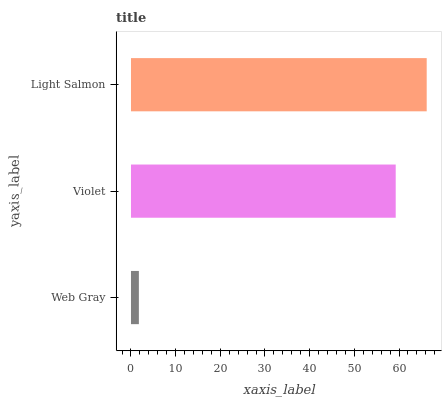Is Web Gray the minimum?
Answer yes or no. Yes. Is Light Salmon the maximum?
Answer yes or no. Yes. Is Violet the minimum?
Answer yes or no. No. Is Violet the maximum?
Answer yes or no. No. Is Violet greater than Web Gray?
Answer yes or no. Yes. Is Web Gray less than Violet?
Answer yes or no. Yes. Is Web Gray greater than Violet?
Answer yes or no. No. Is Violet less than Web Gray?
Answer yes or no. No. Is Violet the high median?
Answer yes or no. Yes. Is Violet the low median?
Answer yes or no. Yes. Is Light Salmon the high median?
Answer yes or no. No. Is Light Salmon the low median?
Answer yes or no. No. 